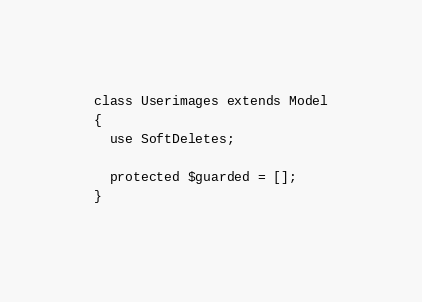<code> <loc_0><loc_0><loc_500><loc_500><_PHP_>
class Userimages extends Model
{
  use SoftDeletes;

  protected $guarded = [];
}
</code> 